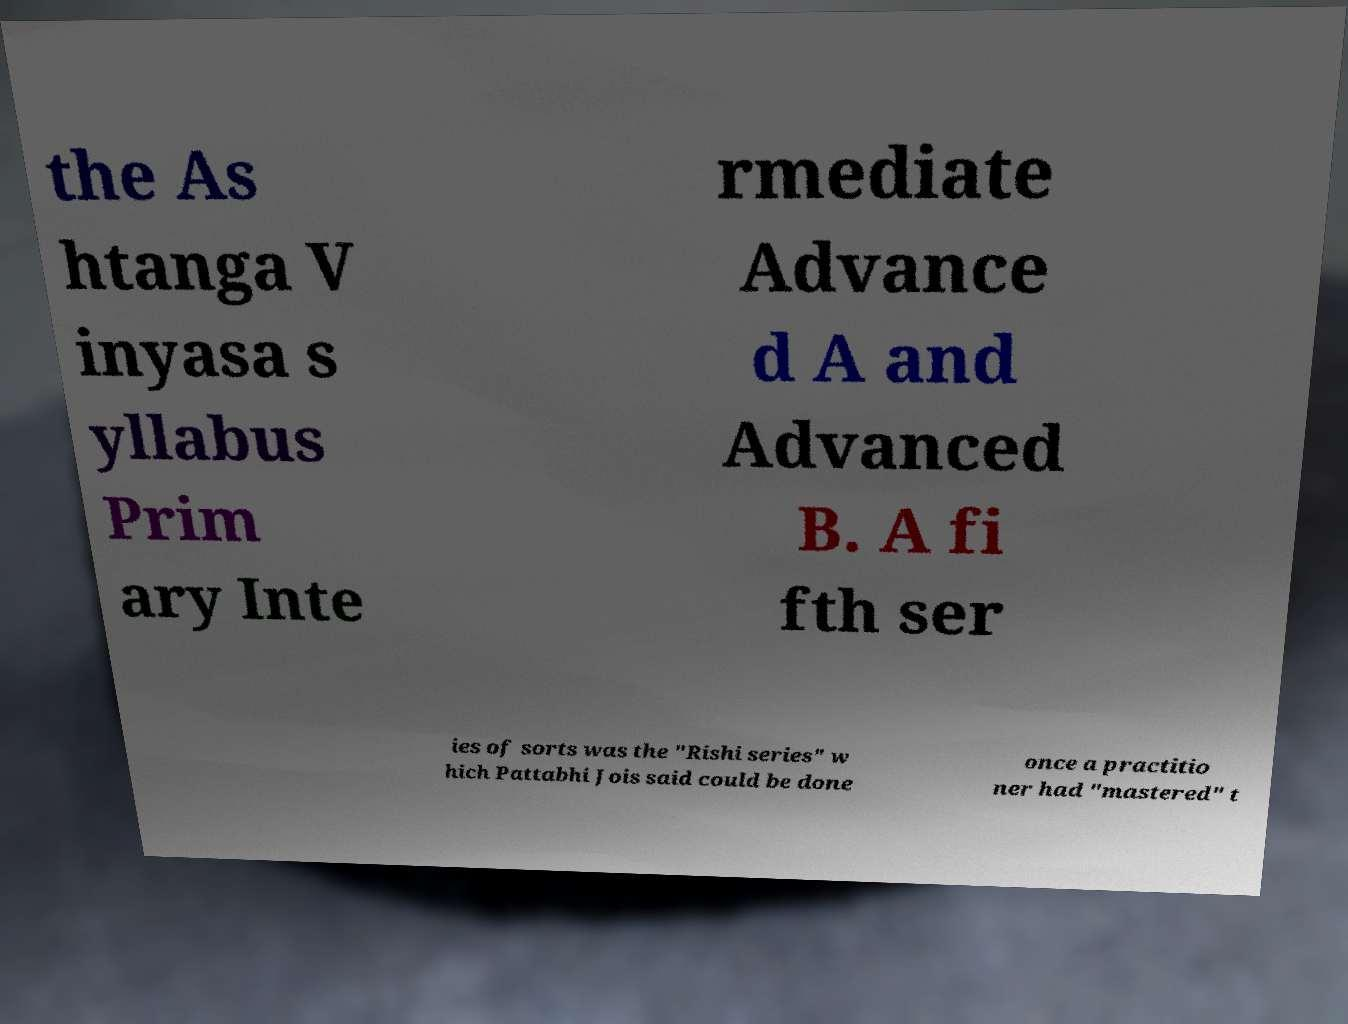Could you extract and type out the text from this image? the As htanga V inyasa s yllabus Prim ary Inte rmediate Advance d A and Advanced B. A fi fth ser ies of sorts was the "Rishi series" w hich Pattabhi Jois said could be done once a practitio ner had "mastered" t 